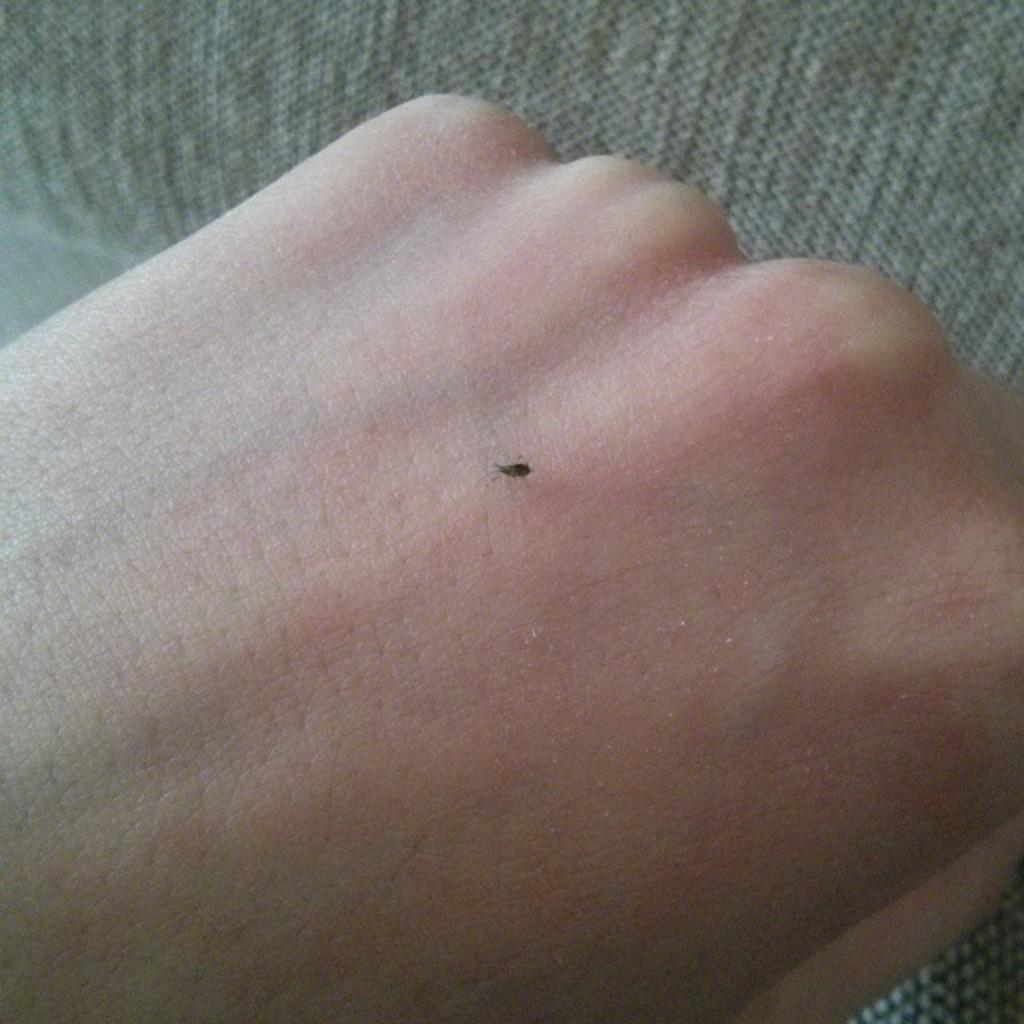What is the main subject of the image? The main subject of the image is the hand of a person. What is present on the hand in the image? There is an insect on the hand in the image. What can be seen in the background of the image? There is a background visible in the image. What type of airplane is visible in the image? There is no airplane present in the image. Is there a box on the hand in the image? No, there is no box present on the hand in the image. What type of payment is being made in the image? There is no payment being made in the image; it features a hand with an insect on it. 